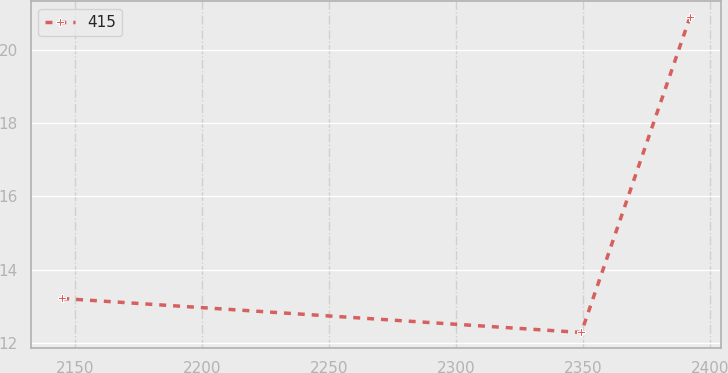<chart> <loc_0><loc_0><loc_500><loc_500><line_chart><ecel><fcel>415<nl><fcel>2145.11<fcel>13.21<nl><fcel>2349.38<fcel>12.28<nl><fcel>2392.18<fcel>20.91<nl></chart> 